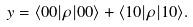<formula> <loc_0><loc_0><loc_500><loc_500>y = \langle 0 0 | \rho | 0 0 \rangle + \langle 1 0 | \rho | 1 0 \rangle .</formula> 